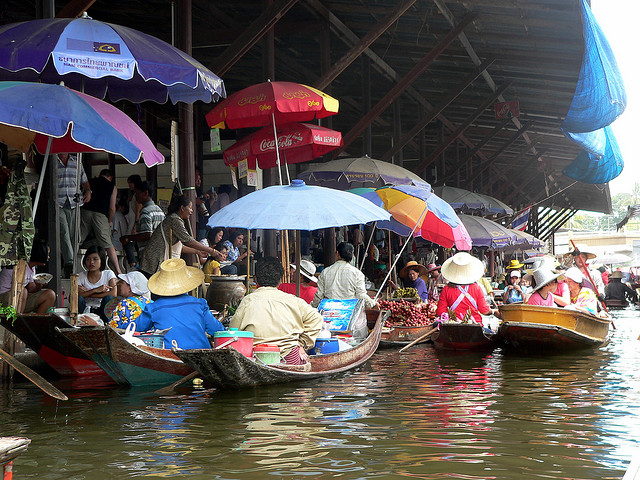Identify the text displayed in this image. Coca Cola 